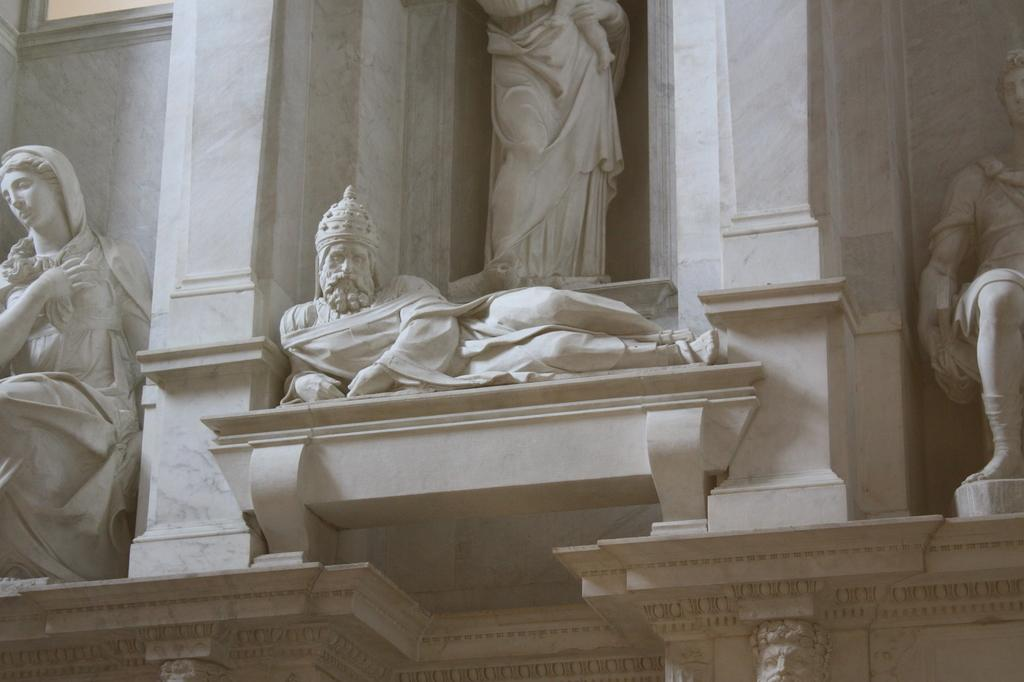What are the four persons depicted as doing in the image? The four persons are sculpted on a wall, so they are not actively doing anything in the image. What type of building might the image have been taken in, considering the presence of sculptures and pillars? The image may have been taken in a church, as the presence of sculptures and pillars is common in religious architecture. How does the person holding the camera grip the fuel in the image? There is no person holding a camera or fuel in the image; it only shows sculptures on a wall. --- Conversation: What is the person in the image doing? The person in the image is holding a camera and taking a picture. What can be seen in the background of the image? There is a building in the background of the image. Reasoning: Let's think step by step in order to produce the conversation. We start by identifying the main subject in the image, which is the person holding a camera. Then, we formulate a question that focuses on the action or activity of the person, which is taking a picture. Finally, we expand the conversation to include the background of the image, which is a building. Absurd Question/Answer: How does the person in the image walk while washing the car? There is no person walking or washing a car in the image; it only shows a person holding a camera and taking a picture of a building. --- Conversation: What is the person in the image doing? The person in the image is sitting on a chair and reading a book. What is located in front of the person? There is a table in front of the person. Reasoning: Let's think step by step in order to produce the conversation. We start by identifying the main subject in the image, which is the person sitting on a chair. Then, we formulate a question that focuses on the action or activity of the person, which is reading a book. Finally, we expand the conversation to include the object located in front of the person, which is a table. Absurd Question/Answer: How does the person in the image grip the crib while reading the book? There is no crib present in the image; it only shows a person sitting on a chair and reading a book with a table in front of them. --- Conversation: What are the people in the image doing near a car? The people in the image are standing near a car. What color is the car? The car is red in color. Reasoning: Let's think step by step in order to produce the conversation. We start by identifying the main subjects and objects in the image. We then formulate questions that focus on the location and characteristics of these subjects and objects, ensuring that each question can be answered definitively with the information given. We avoid yes/no questions and ensure that the language 